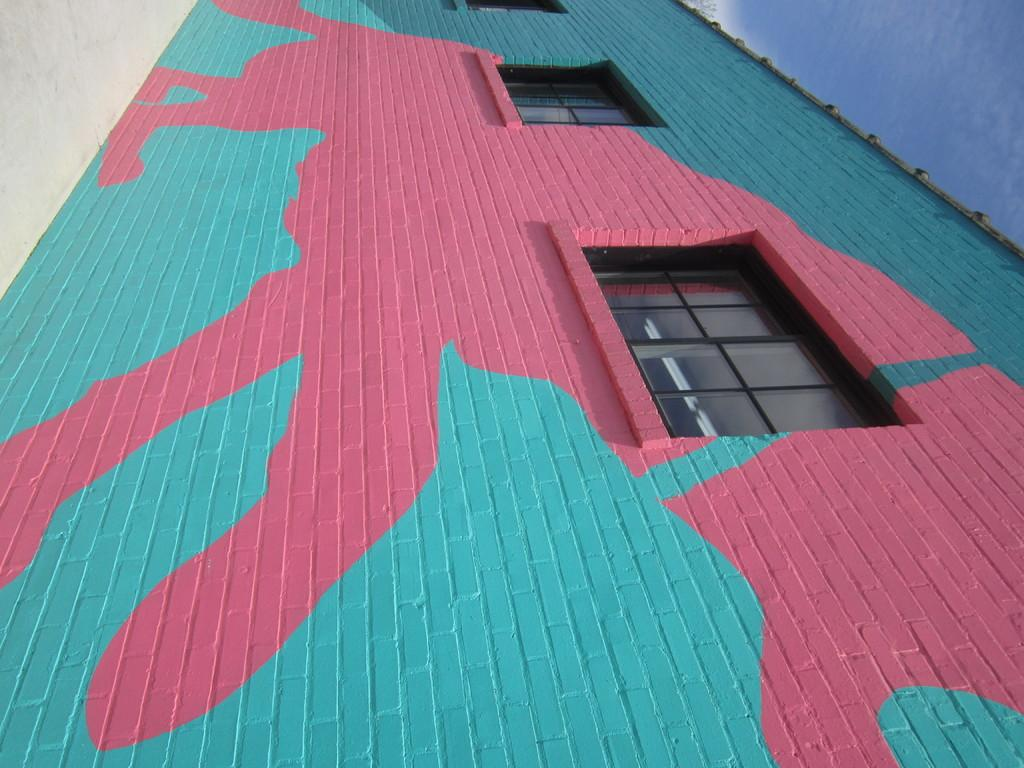What type of structure is present in the image? There is a building in the image. What feature can be seen on the building? The building has windows. What part of the natural environment is visible in the image? The sky is visible in the image. Based on the presence of the sky and the absence of any visible light sources, can we infer the time of day when the image was taken? Yes, the image was likely taken during the day. Can you see any rabbits hopping around the building in the image? No, there are no rabbits visible in the image. What act is the building performing in the image? Buildings do not perform acts; they are inanimate structures. 